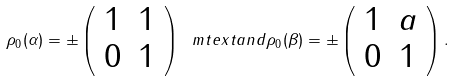<formula> <loc_0><loc_0><loc_500><loc_500>\rho _ { 0 } ( \alpha ) = \pm \left ( \begin{array} { c c } 1 & 1 \\ 0 & 1 \end{array} \right ) \ m t e x t { a n d } \rho _ { 0 } ( \beta ) = \pm \left ( \begin{array} { c c } 1 & a \\ 0 & 1 \end{array} \right ) .</formula> 